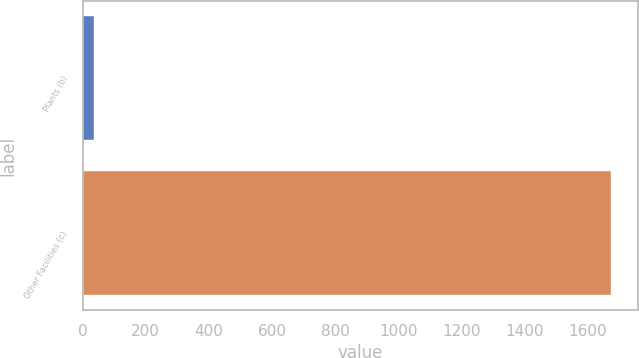<chart> <loc_0><loc_0><loc_500><loc_500><bar_chart><fcel>Plants (b)<fcel>Other Facilities (c)<nl><fcel>35<fcel>1675<nl></chart> 